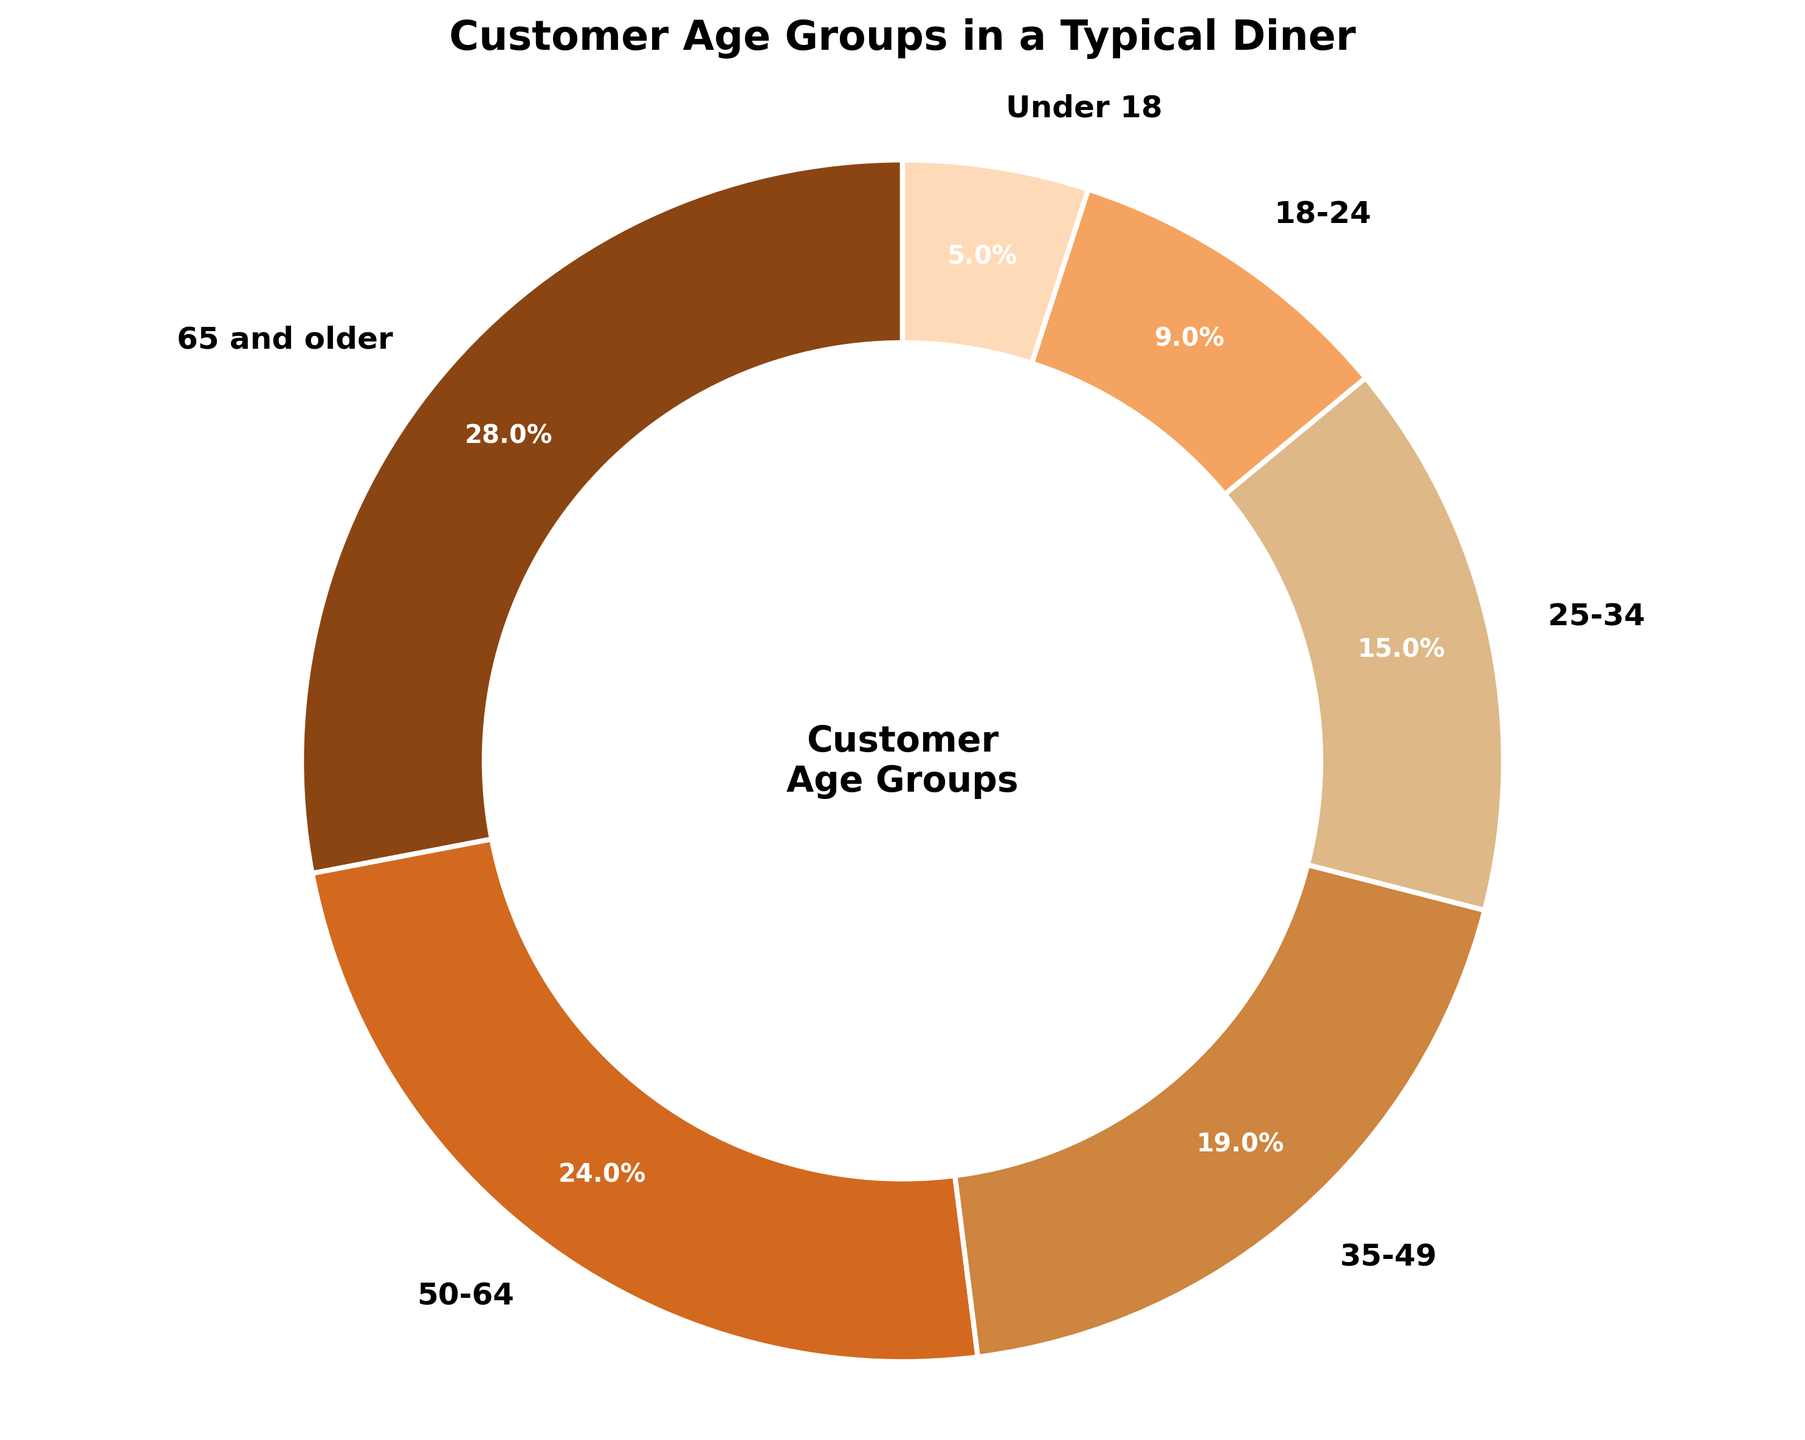Which age group has the highest percentage? The age group "65 and older" has the largest wedge in the pie chart with a label indicating 28%.
Answer: 65 and older What is the total percentage of customers aged 50 and above? Combine the percentages of "50-64" (24%) and "65 and older" (28%). Summing these gives 24% + 28% = 52%.
Answer: 52% Which age group has the smallest representation? The "Under 18" age group has the smallest wedge in the pie chart, marked with a label showing 5%.
Answer: Under 18 How much larger is the percentage of customers aged 65 and older compared to those aged 18-24? Subtract the percentage of the "18-24" group (9%) from the "65 and older" group (28%). This gives 28% - 9% = 19%.
Answer: 19% What's the percentage difference between the 25-34 and 35-49 age groups? Subtract the percentage of the "25-34" group (15%) from the "35-49" group (19%). This gives 19% - 15% = 4%.
Answer: 4% Combine the percentages of customers aged under 18 and those aged 18-24. What is the total? Sum the percentages of "Under 18" (5%) and "18-24" (9%). This gives 5% + 9% = 14%.
Answer: 14% Which color represents the 50-64 age group? The pie chart segment for the "50-64" age group is colored in a certain hue. This segment is shown in the orange-brown shade.
Answer: Orange-brown How many age groups have percentages greater than 20%? Identify and count the segments with percentages higher than 20%. The groups are "65 and older" (28%) and "50-64" (24%). So, there are 2 groups.
Answer: 2 If we combined the age groups from 18 to 34, what percentage of the total would they represent? Sum the percentages of the "18-24" group (9%) and the "25-34" group (15%). This gives 9% + 15% = 24%.
Answer: 24% Is the percentage of customers from the "35-49" group larger than the combined "Under 18" and "18-24" groups? Calculate the combined percentage of "Under 18" (5%) and "18-24" (9%) groups, which amounts to 5% + 9% = 14%. Compare this to the "35-49" group percentage, which is 19%. Since 19% > 14%, it is larger.
Answer: Yes 